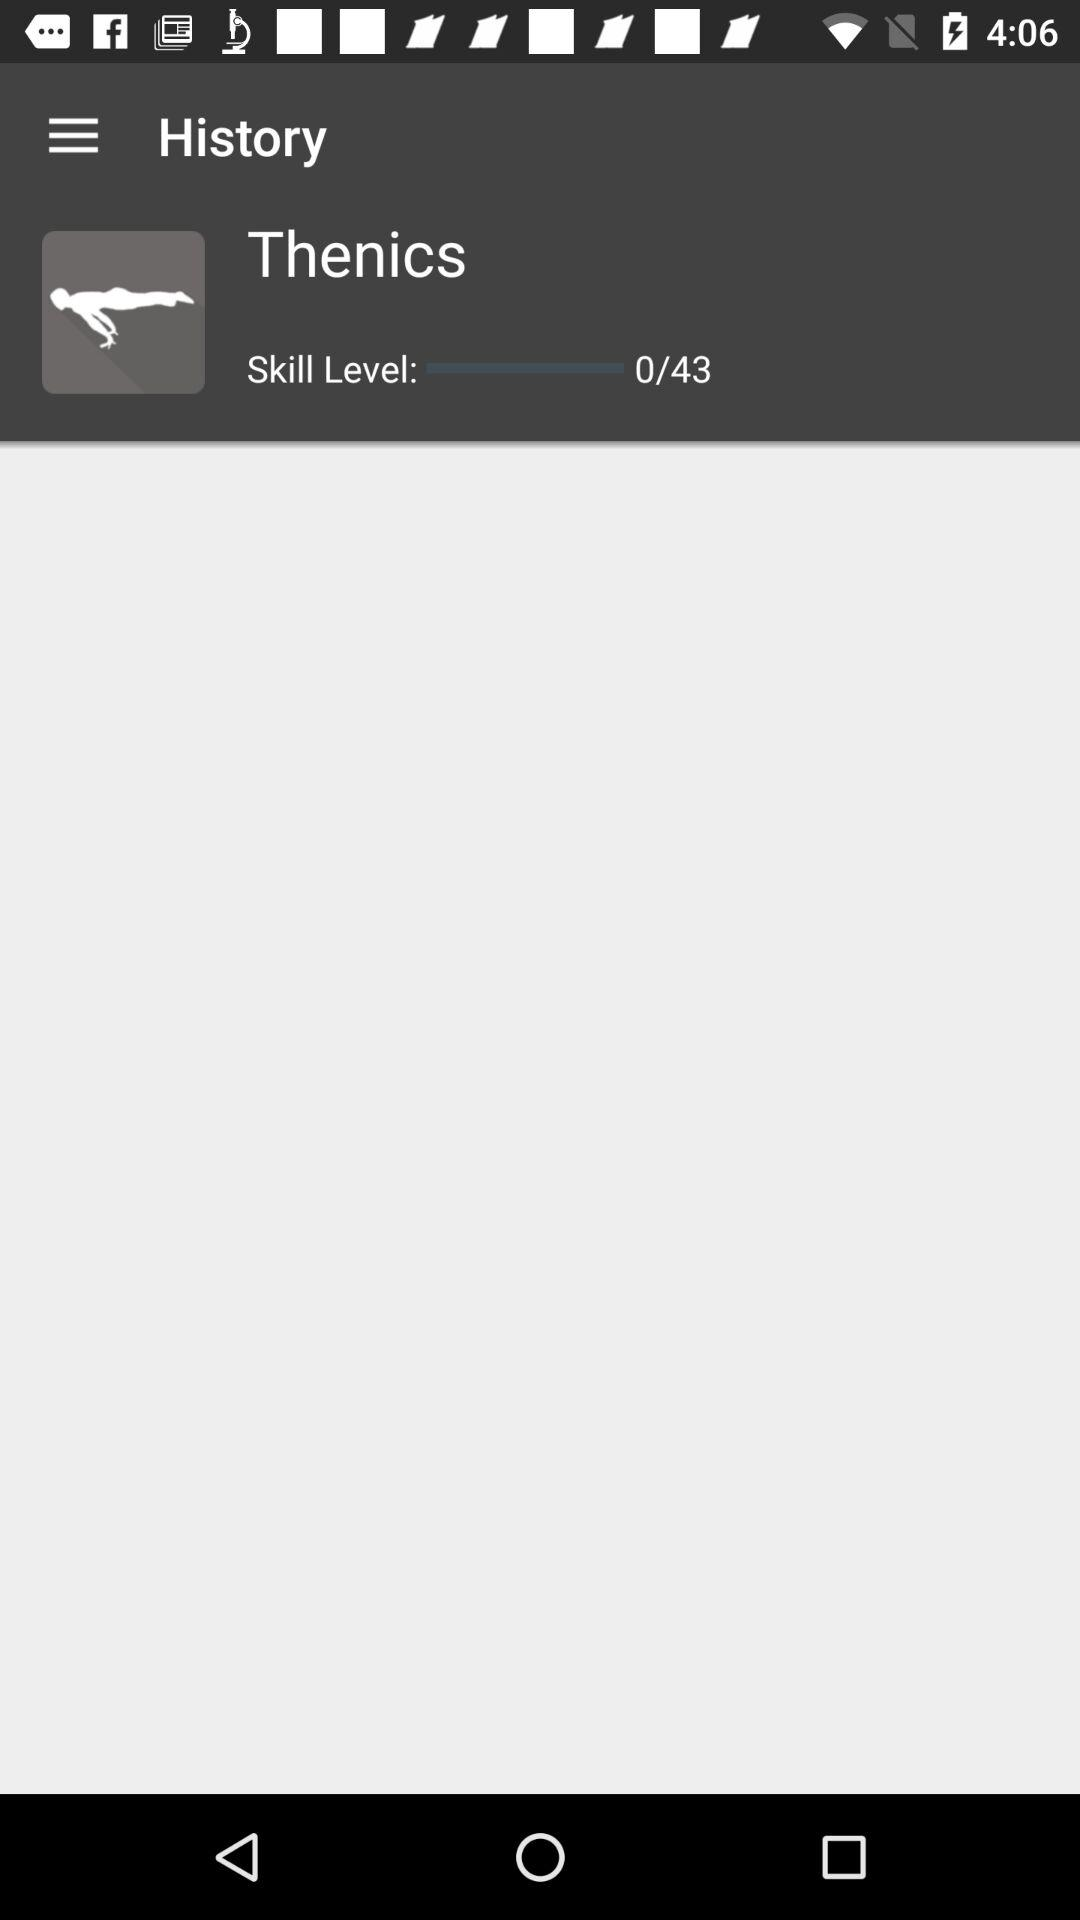How many more points do I need to reach the next skill level?
Answer the question using a single word or phrase. 43 